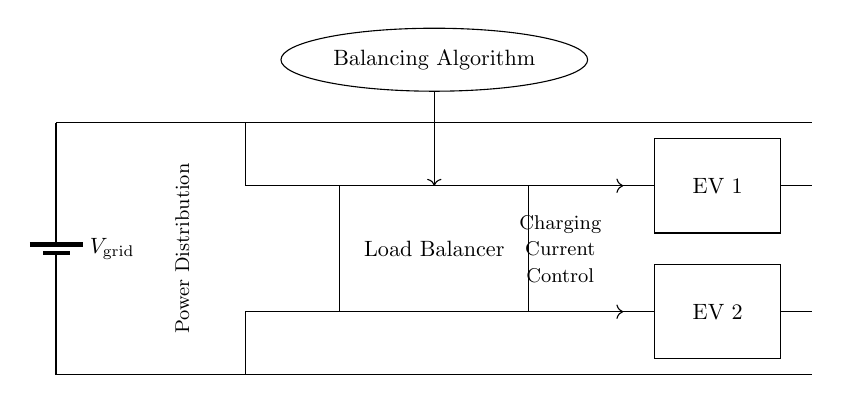What is the name of the component that controls charging? The component responsible for controlling charging in the diagram is the Load Balancer, which distributes the charging current among the electric vehicles.
Answer: Load Balancer How many electric vehicles are shown in the diagram? There are two electric vehicles connected in the circuit, identified as EV 1 and EV 2.
Answer: Two What does the diagonal arrow signify in the circuit? The diagonal arrows signify the direction of the charging current flow from the Load Balancer to each of the electric vehicle chargers.
Answer: Charging current flow What is the main function of the Balancing Algorithm in this circuit? The Balancing Algorithm is responsible for managing the distribution of electric power to ensure that both vehicles are charged efficiently without exceeding the grid's capability.
Answer: Manage power distribution What components are connected in parallel between the Load Balancer and the electric vehicles? The Load Balancer connects to both EV 1 and EV 2 in parallel, allowing them to draw current independently from the same source.
Answer: EV 1 and EV 2 What element provides the voltage in this circuit? The voltage is provided by the grid battery, represented as the source of voltage at the top of the circuit diagram.
Answer: Grid battery 